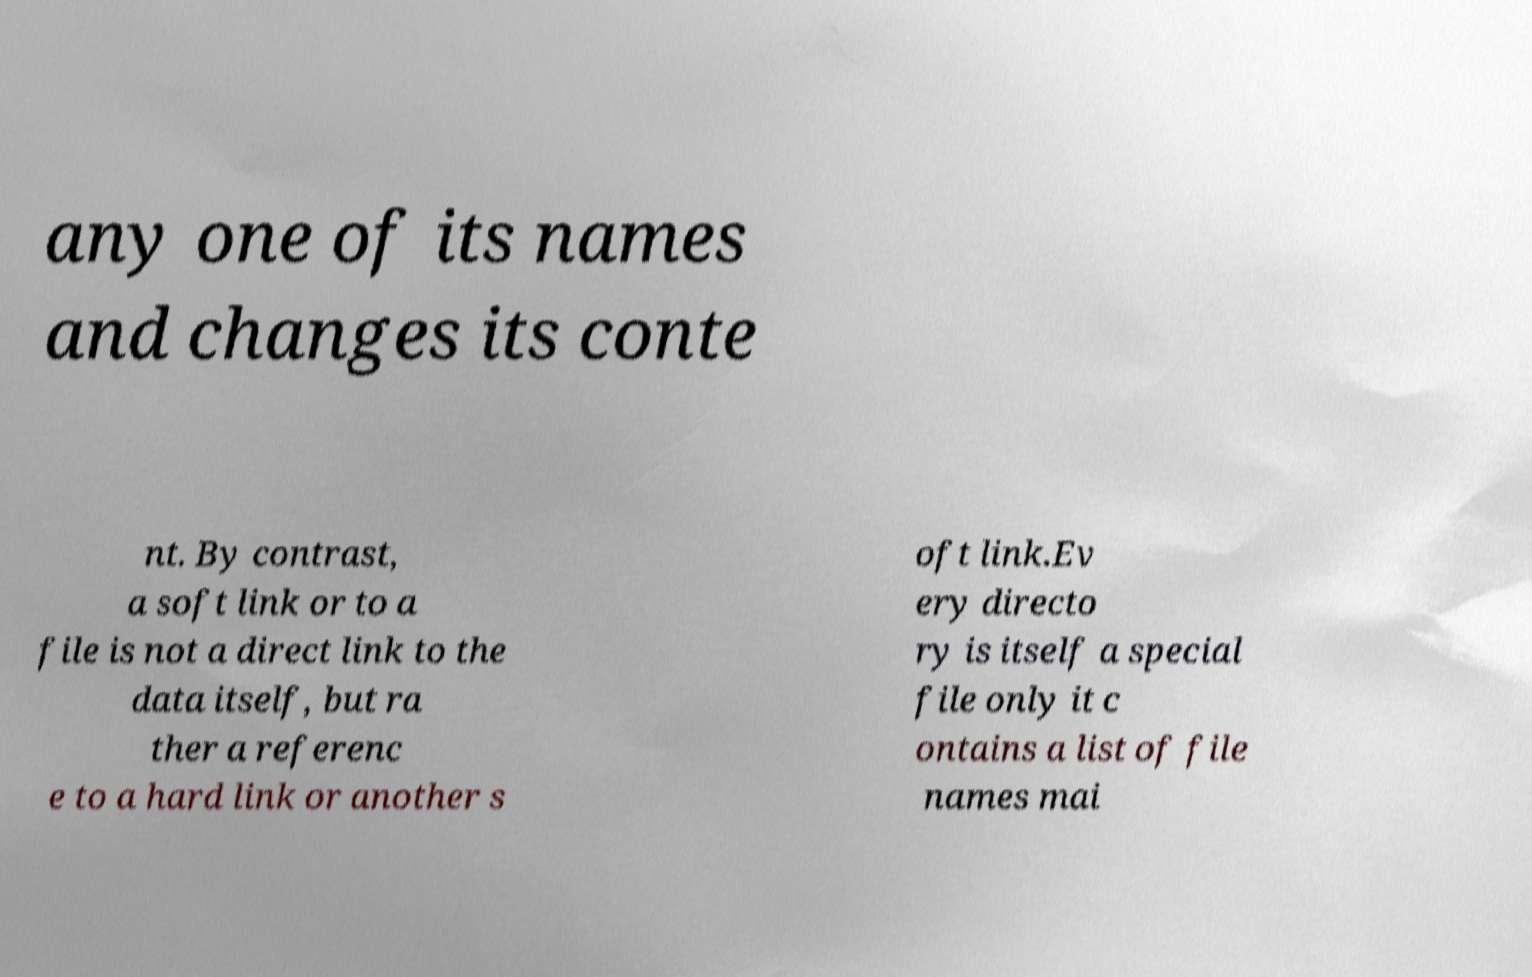Can you accurately transcribe the text from the provided image for me? any one of its names and changes its conte nt. By contrast, a soft link or to a file is not a direct link to the data itself, but ra ther a referenc e to a hard link or another s oft link.Ev ery directo ry is itself a special file only it c ontains a list of file names mai 